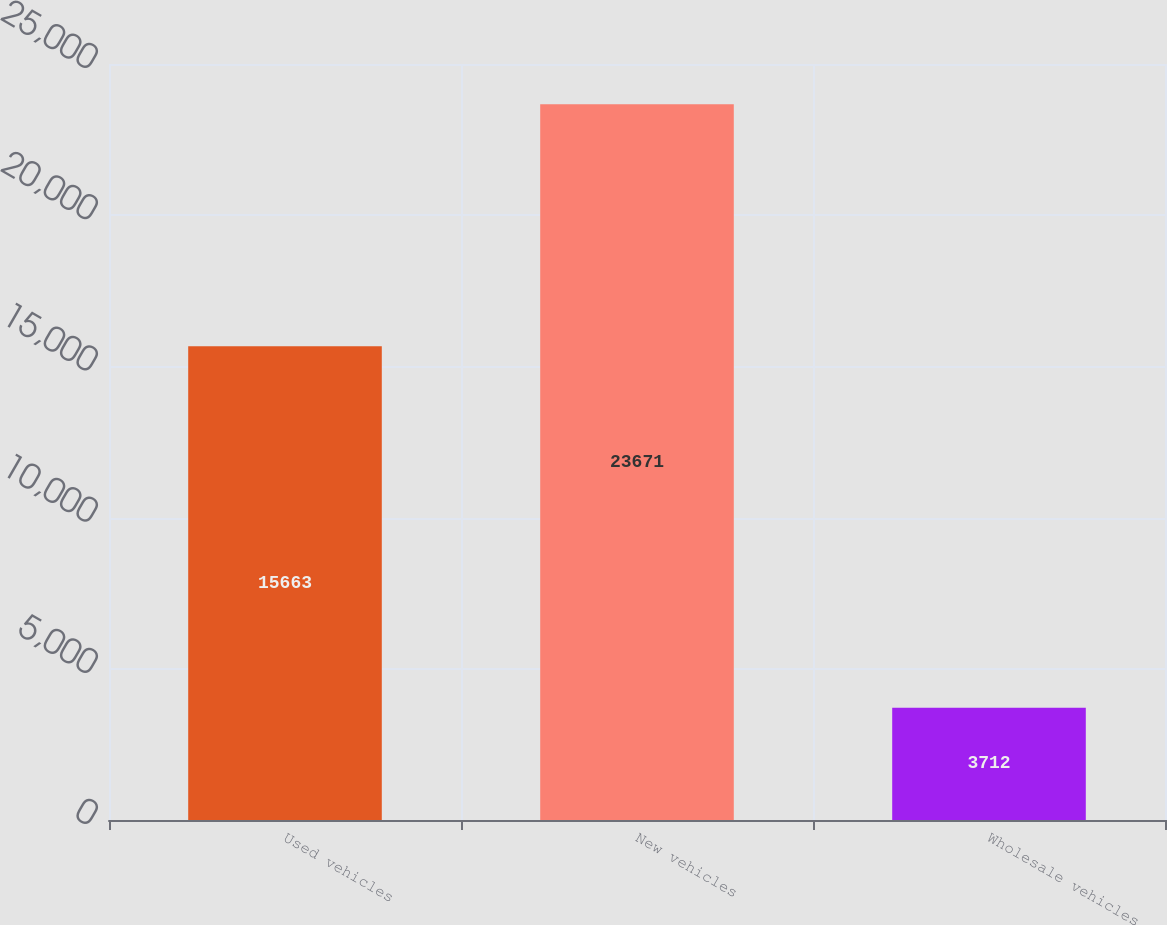Convert chart to OTSL. <chart><loc_0><loc_0><loc_500><loc_500><bar_chart><fcel>Used vehicles<fcel>New vehicles<fcel>Wholesale vehicles<nl><fcel>15663<fcel>23671<fcel>3712<nl></chart> 